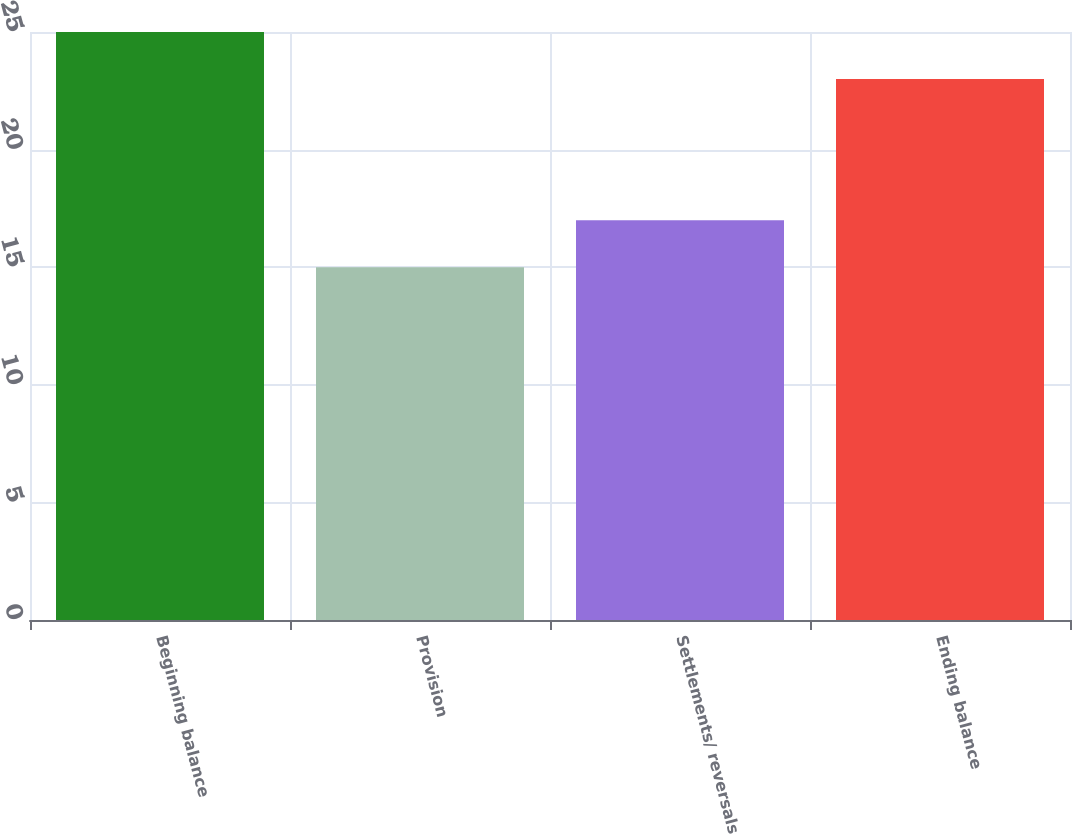<chart> <loc_0><loc_0><loc_500><loc_500><bar_chart><fcel>Beginning balance<fcel>Provision<fcel>Settlements/ reversals<fcel>Ending balance<nl><fcel>25<fcel>15<fcel>17<fcel>23<nl></chart> 